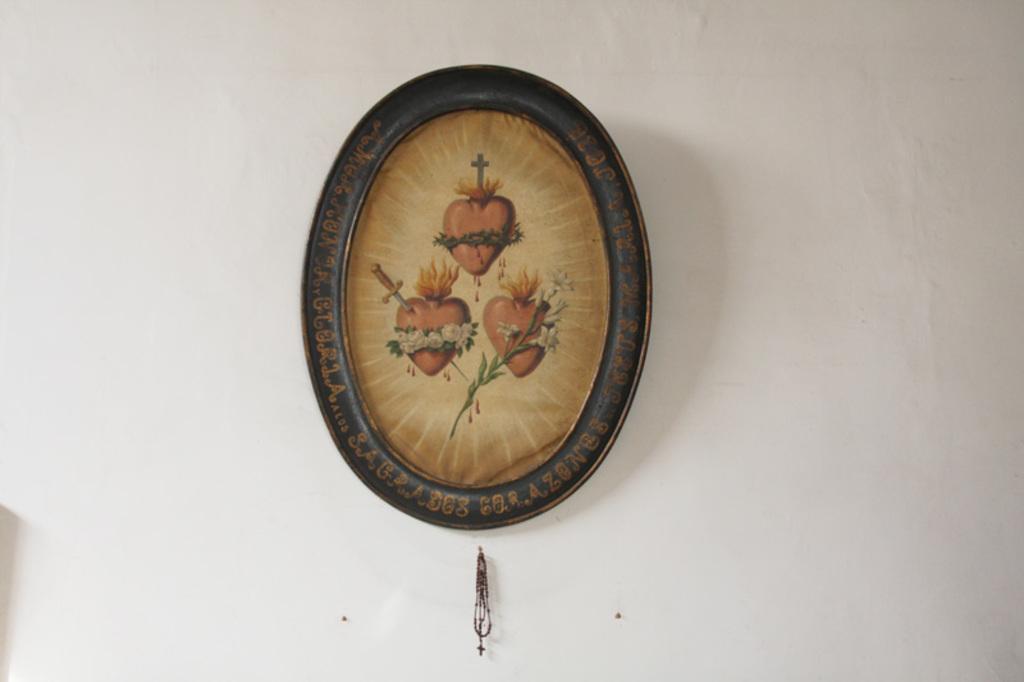In one or two sentences, can you explain what this image depicts? In the middle of the image we can see a frame and a chain on the wall. 